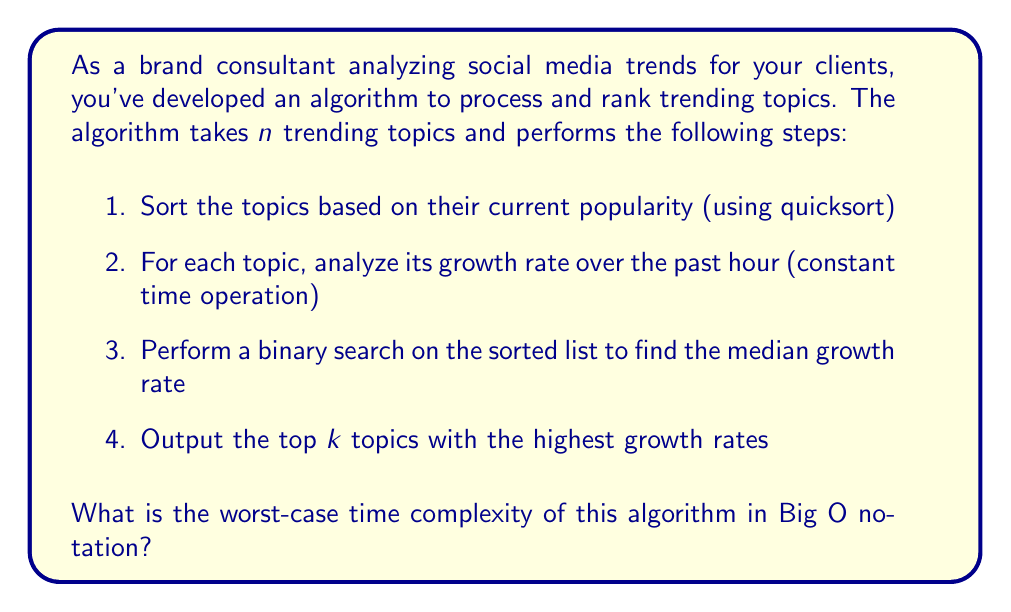Show me your answer to this math problem. To determine the worst-case time complexity, we need to analyze each step of the algorithm:

1. Sorting using quicksort:
   - Worst-case time complexity: $O(n^2)$
   - Average-case time complexity: $O(n \log n)$

2. Analyzing growth rate for each topic:
   - This is a constant time operation for each topic
   - Total time complexity: $O(n)$

3. Binary search for median growth rate:
   - Time complexity: $O(\log n)$

4. Outputting top $k$ topics:
   - Assuming $k$ is constant or $k \ll n$, this step is $O(k)$ or effectively $O(1)$

The overall time complexity is the sum of these steps, dominated by the largest term:

$$T(n) = O(n^2) + O(n) + O(\log n) + O(1)$$

In the worst case, when the quicksort performs poorly, the time complexity is dominated by the $O(n^2)$ term.

It's worth noting that in practice, quicksort's average-case performance of $O(n \log n)$ is more common. However, for worst-case analysis, we consider the highest possible complexity.
Answer: The worst-case time complexity of the algorithm is $O(n^2)$. 